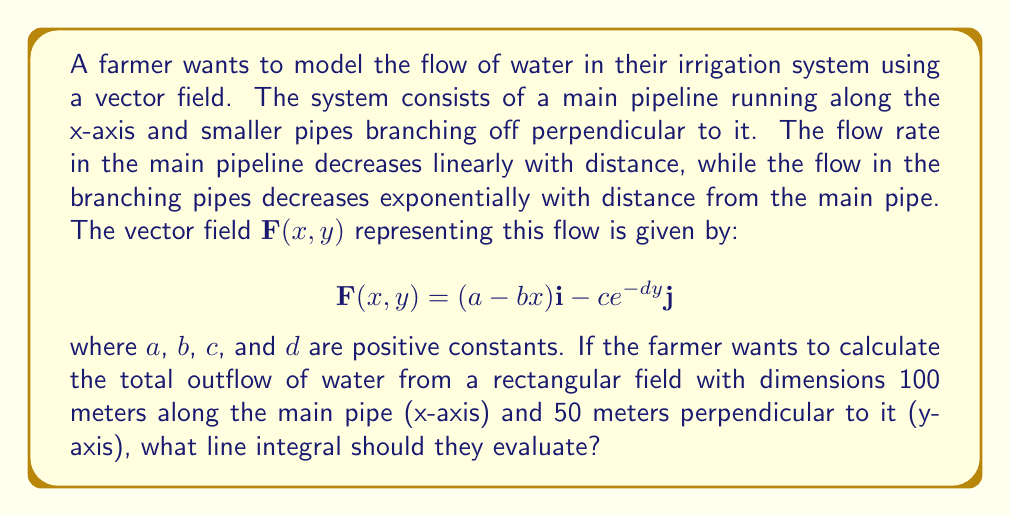Can you answer this question? To solve this problem, we need to understand the concept of flux across a boundary and how it relates to vector fields and line integrals. Here's a step-by-step explanation:

1) The total outflow of water from the field is equivalent to the flux of the vector field across the boundary of the rectangular field.

2) The flux across a closed boundary can be calculated using the line integral of the vector field dotted with the outward unit normal vector along the boundary.

3) For our rectangular field, we need to evaluate the line integral along four sides:
   - Bottom: from (0,0) to (100,0)
   - Right: from (100,0) to (100,50)
   - Top: from (100,50) to (0,50)
   - Left: from (0,50) to (0,0)

4) The outward unit normal vectors for each side are:
   - Bottom: $\mathbf{n} = -\mathbf{j}$
   - Right: $\mathbf{n} = \mathbf{i}$
   - Top: $\mathbf{n} = \mathbf{j}$
   - Left: $\mathbf{n} = -\mathbf{i}$

5) The line integral to calculate the total flux is:

   $$\oint_C \mathbf{F} \cdot \mathbf{n} \, ds$$

   where $C$ is the closed path around the rectangle.

6) Expanding this for each side:

   $$\int_0^{100} (a-bx,0) \cdot (0,-1) \, dx + \int_0^{50} (a-100b,-ce^{-dy}) \cdot (1,0) \, dy$$
   $$+ \int_{100}^0 (a-bx,-ce^{-50d}) \cdot (0,1) \, dx + \int_{50}^0 (a,-ce^{-dy}) \cdot (-1,0) \, dy$$

This is the line integral that the farmer should evaluate to calculate the total outflow of water from their rectangular field.
Answer: $$\oint_C \mathbf{F} \cdot \mathbf{n} \, ds = \int_0^{100} (a-bx,0) \cdot (0,-1) \, dx + \int_0^{50} (a-100b,-ce^{-dy}) \cdot (1,0) \, dy + \int_{100}^0 (a-bx,-ce^{-50d}) \cdot (0,1) \, dx + \int_{50}^0 (a,-ce^{-dy}) \cdot (-1,0) \, dy$$ 